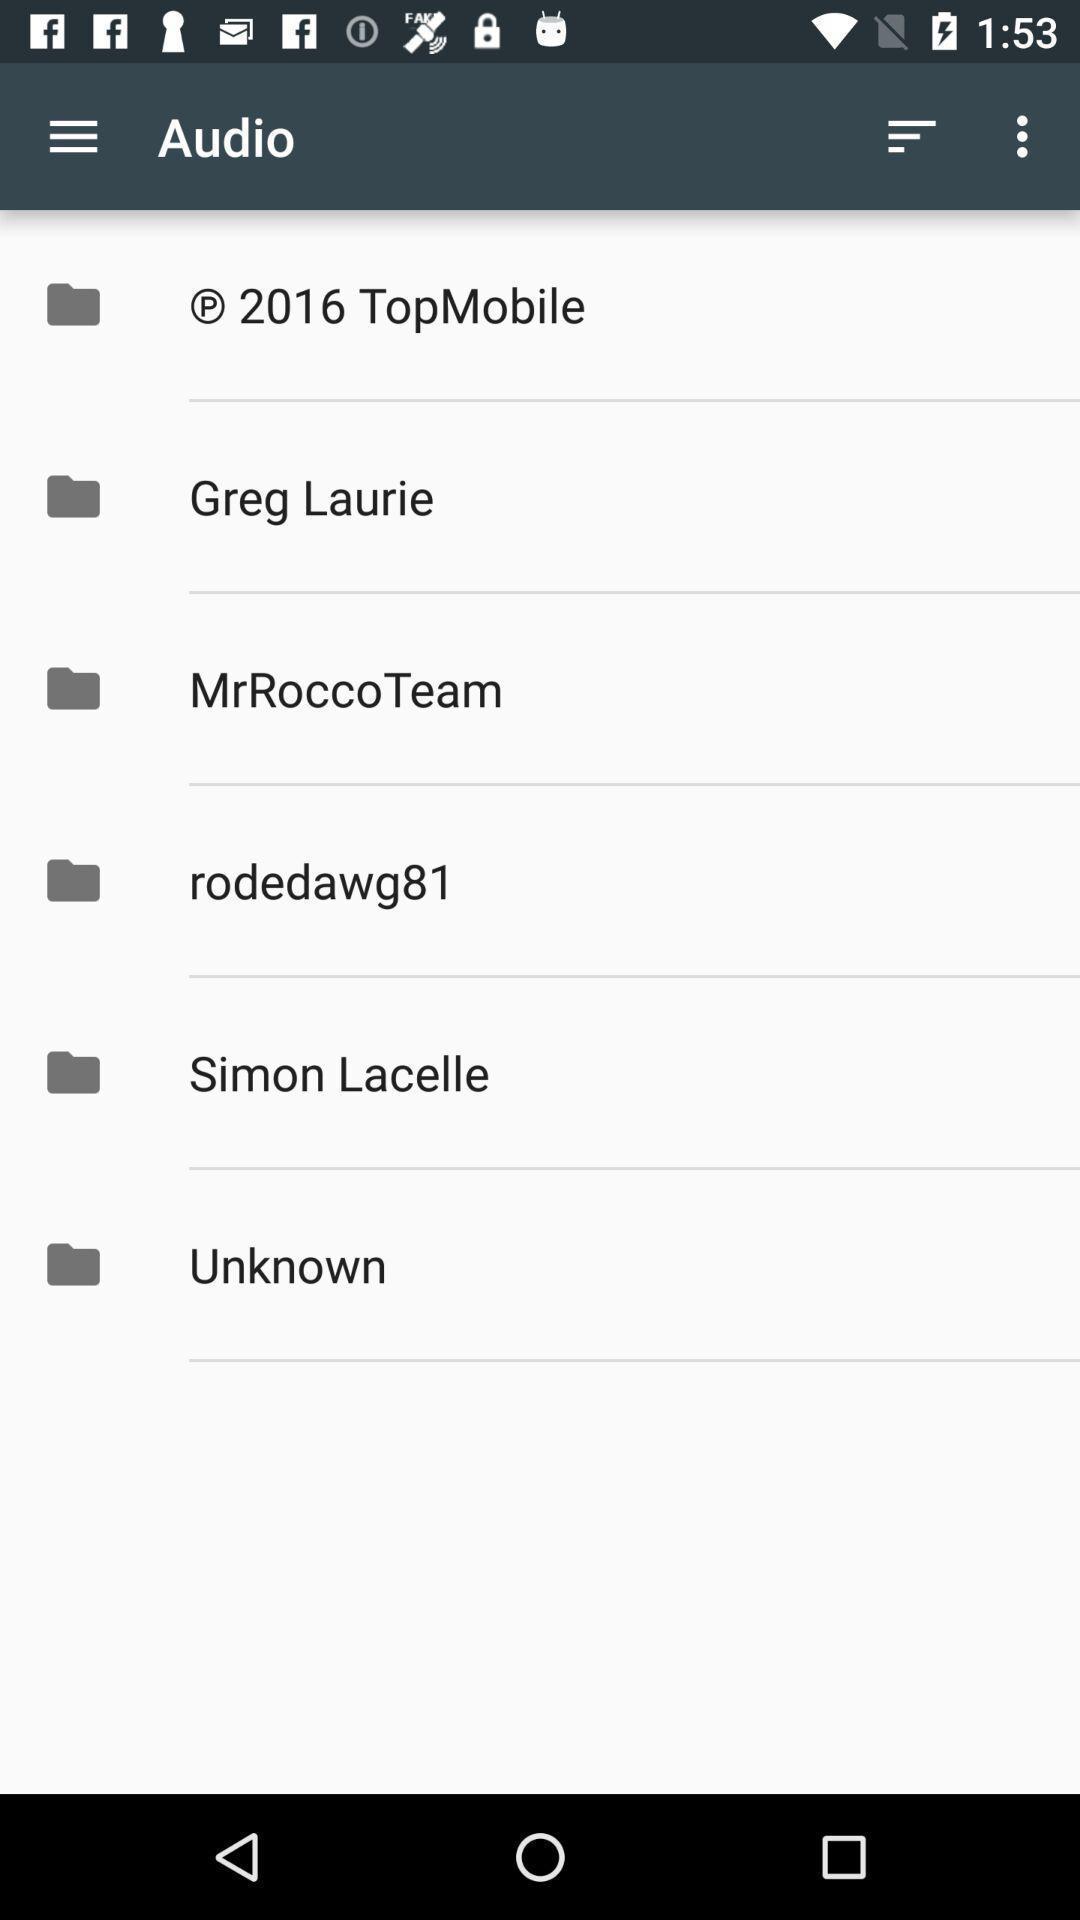Provide a textual representation of this image. Page shows list of folders in the audio application. 